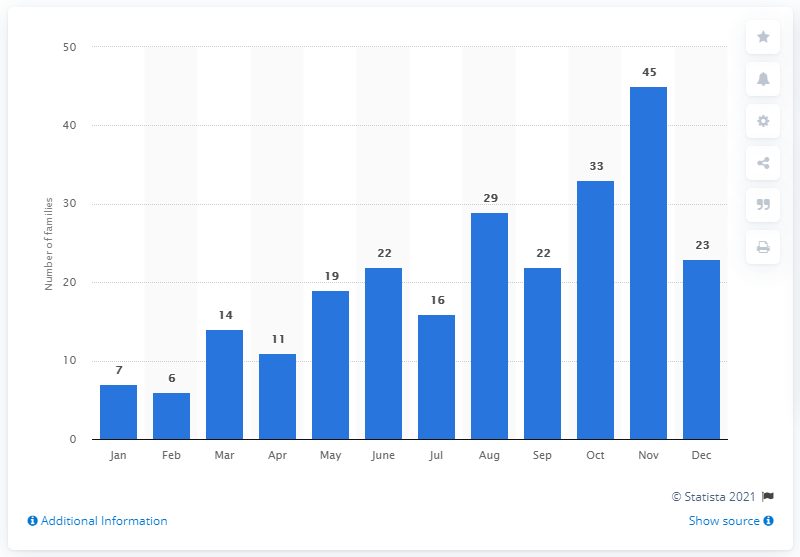Identify some key points in this picture. In June 2016, a total of 22 new ransomware families were added worldwide. 